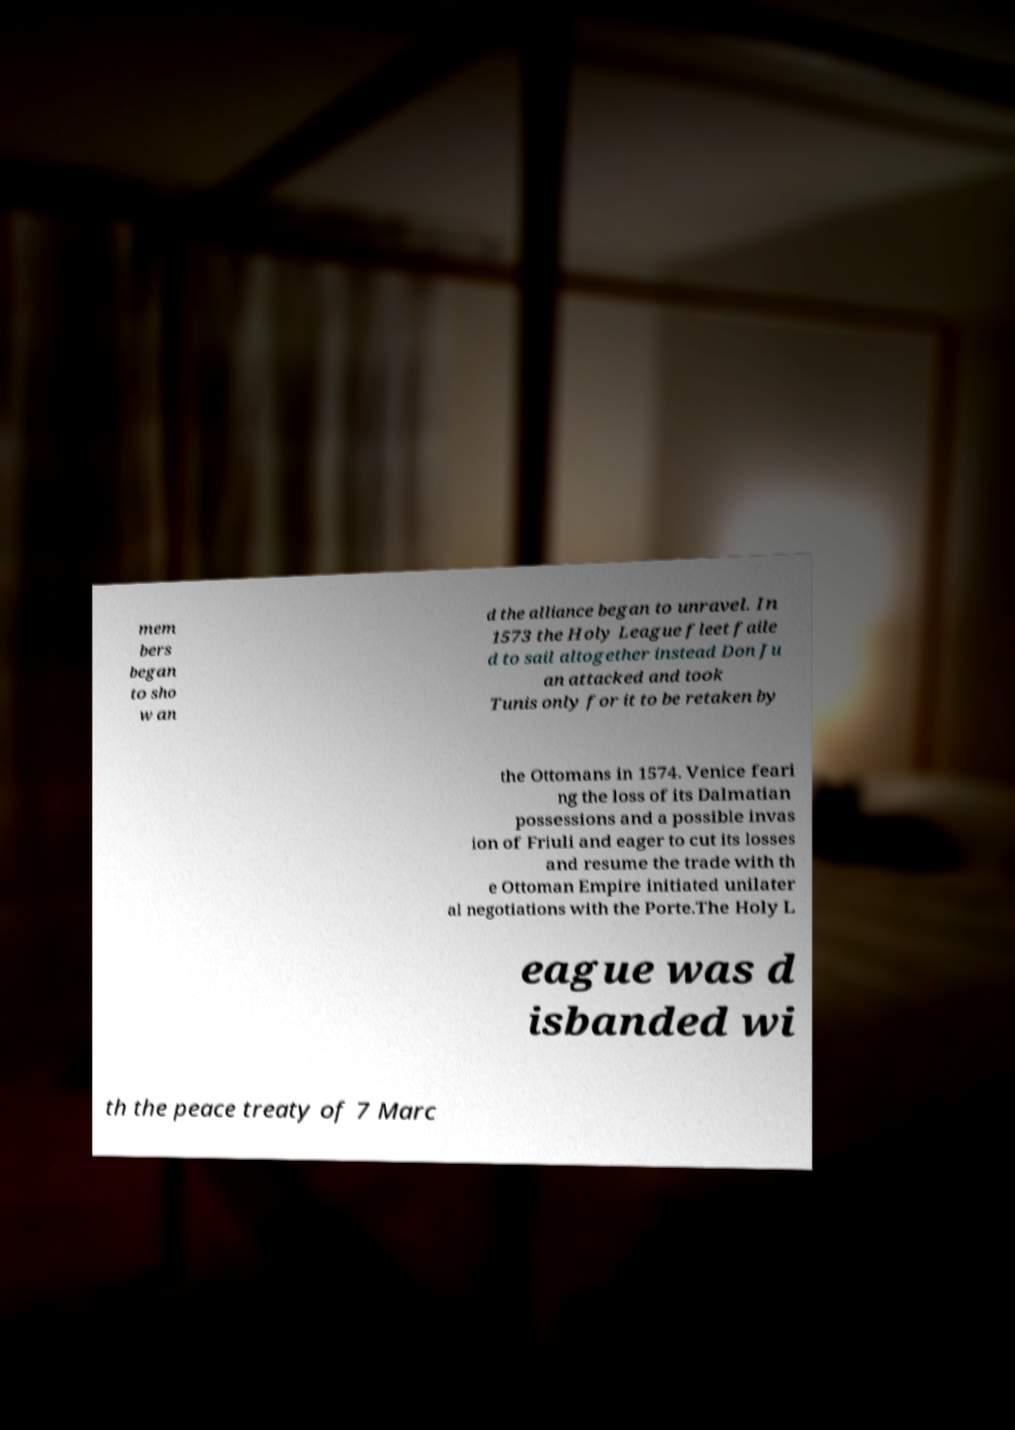Could you assist in decoding the text presented in this image and type it out clearly? mem bers began to sho w an d the alliance began to unravel. In 1573 the Holy League fleet faile d to sail altogether instead Don Ju an attacked and took Tunis only for it to be retaken by the Ottomans in 1574. Venice feari ng the loss of its Dalmatian possessions and a possible invas ion of Friuli and eager to cut its losses and resume the trade with th e Ottoman Empire initiated unilater al negotiations with the Porte.The Holy L eague was d isbanded wi th the peace treaty of 7 Marc 